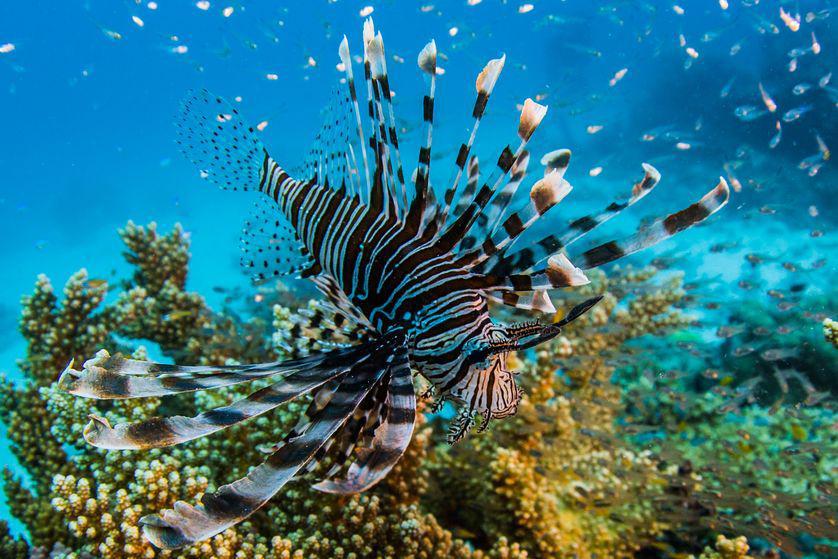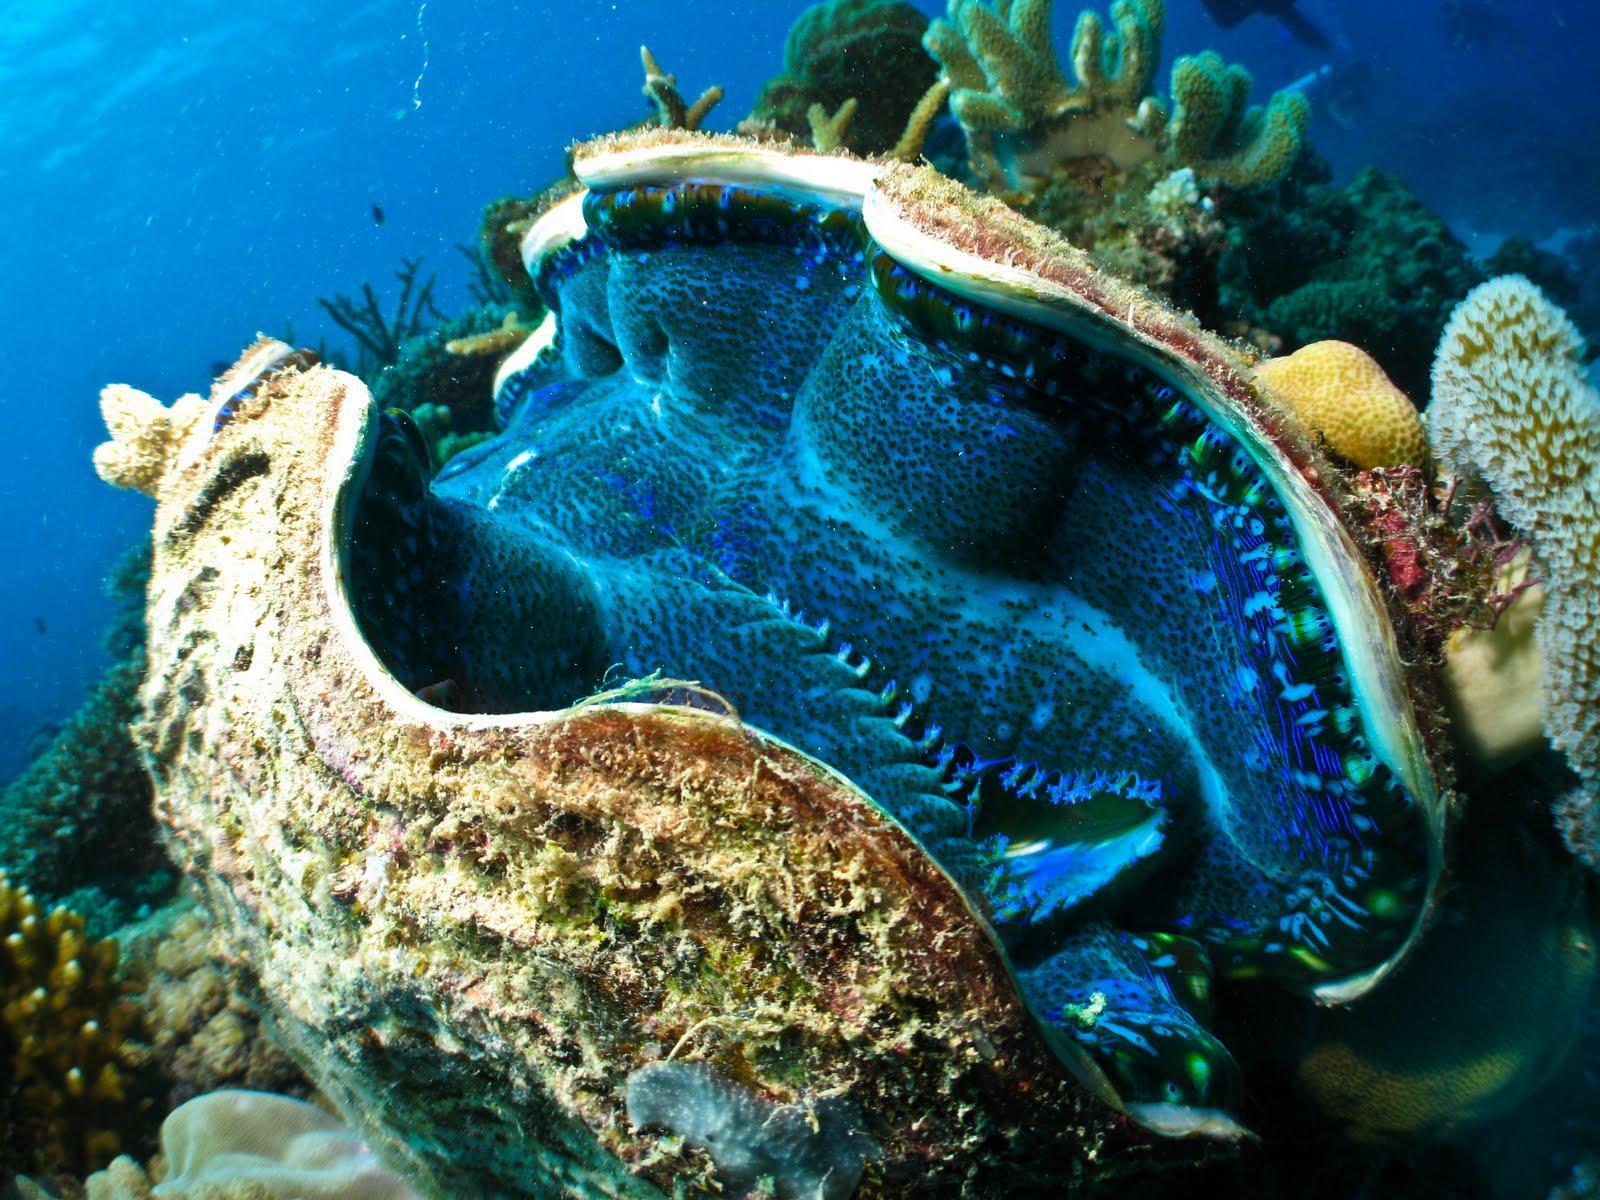The first image is the image on the left, the second image is the image on the right. Examine the images to the left and right. Is the description "There is a single clownfish swimming by the reef." accurate? Answer yes or no. No. 